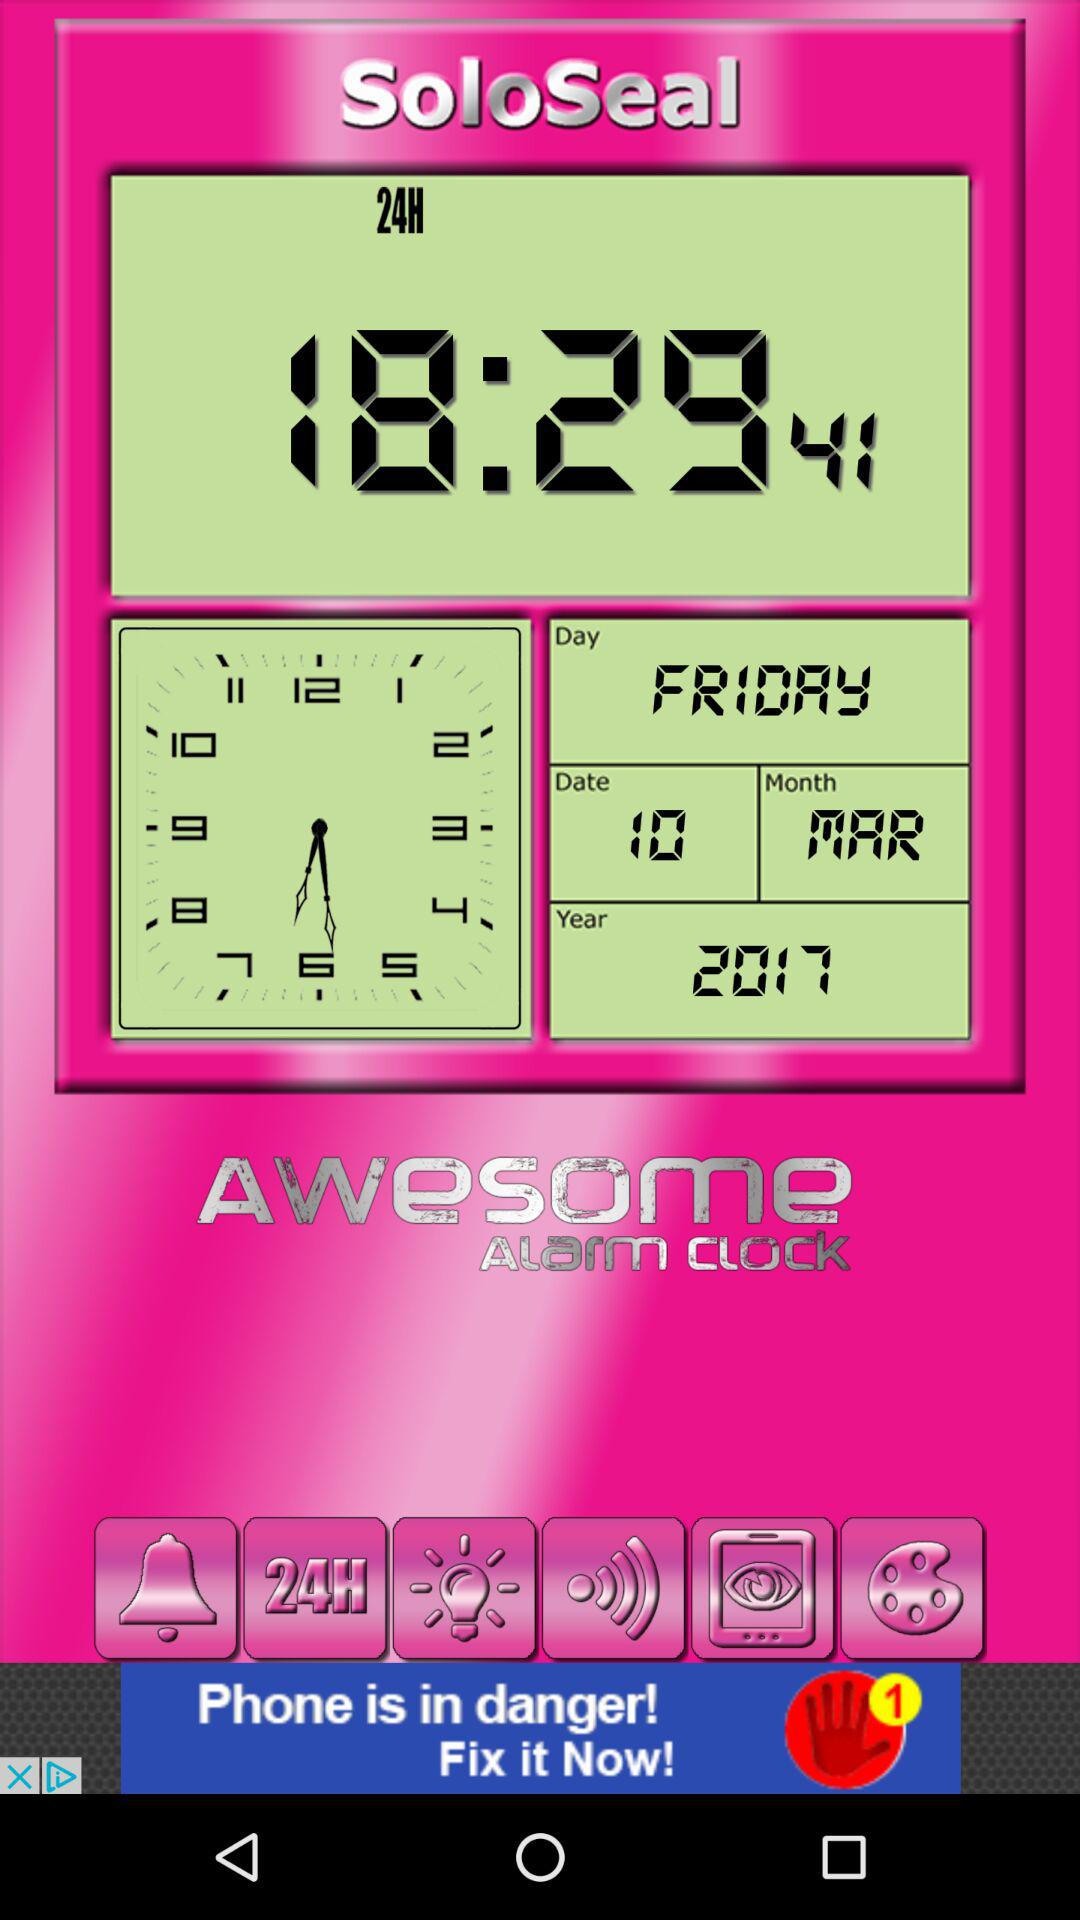What is the month? The month is March. 